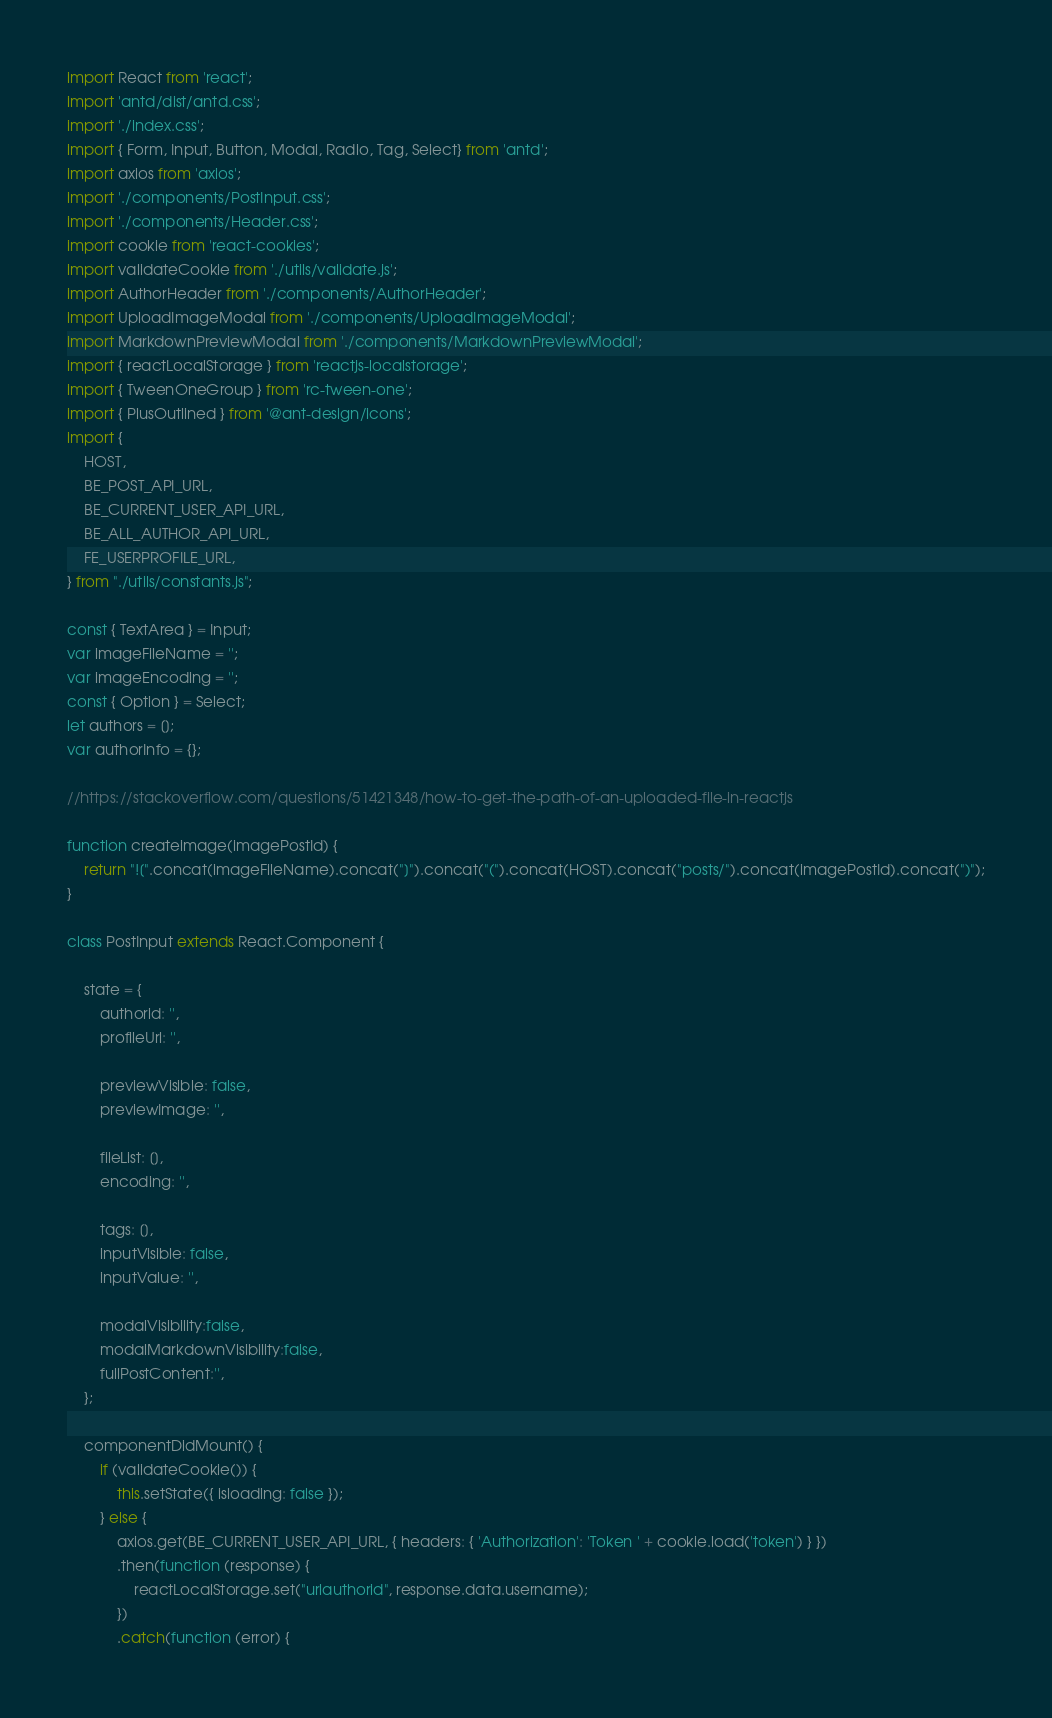<code> <loc_0><loc_0><loc_500><loc_500><_JavaScript_>import React from 'react';
import 'antd/dist/antd.css';
import './index.css';
import { Form, Input, Button, Modal, Radio, Tag, Select} from 'antd';
import axios from 'axios';
import './components/PostInput.css';
import './components/Header.css';
import cookie from 'react-cookies';
import validateCookie from './utils/validate.js';
import AuthorHeader from './components/AuthorHeader';
import UploadImageModal from './components/UploadImageModal';
import MarkdownPreviewModal from './components/MarkdownPreviewModal';
import { reactLocalStorage } from 'reactjs-localstorage';
import { TweenOneGroup } from 'rc-tween-one';
import { PlusOutlined } from '@ant-design/icons';
import { 
    HOST,
    BE_POST_API_URL, 
    BE_CURRENT_USER_API_URL, 
    BE_ALL_AUTHOR_API_URL,
    FE_USERPROFILE_URL, 
} from "./utils/constants.js";

const { TextArea } = Input;
var imageFileName = '';
var imageEncoding = '';
const { Option } = Select;
let authors = [];
var authorInfo = {};

//https://stackoverflow.com/questions/51421348/how-to-get-the-path-of-an-uploaded-file-in-reactjs

function createimage(imagePostId) {
    return "![".concat(imageFileName).concat("]").concat("(").concat(HOST).concat("posts/").concat(imagePostId).concat(")");
}

class PostInput extends React.Component {

    state = {
        authorid: '',
        profileUrl: '',

        previewVisible: false,
        previewImage: '',

        fileList: [],
        encoding: '',

        tags: [],
        inputVisible: false,
        inputValue: '',
        
        modalVisibility:false,
        modalMarkdownVisibility:false,
        fullPostContent:'',
    };

    componentDidMount() {
        if (validateCookie()) {
            this.setState({ isloading: false });
        } else {
            axios.get(BE_CURRENT_USER_API_URL, { headers: { 'Authorization': 'Token ' + cookie.load('token') } })
            .then(function (response) {
                reactLocalStorage.set("urlauthorid", response.data.username);
            })
            .catch(function (error) {</code> 